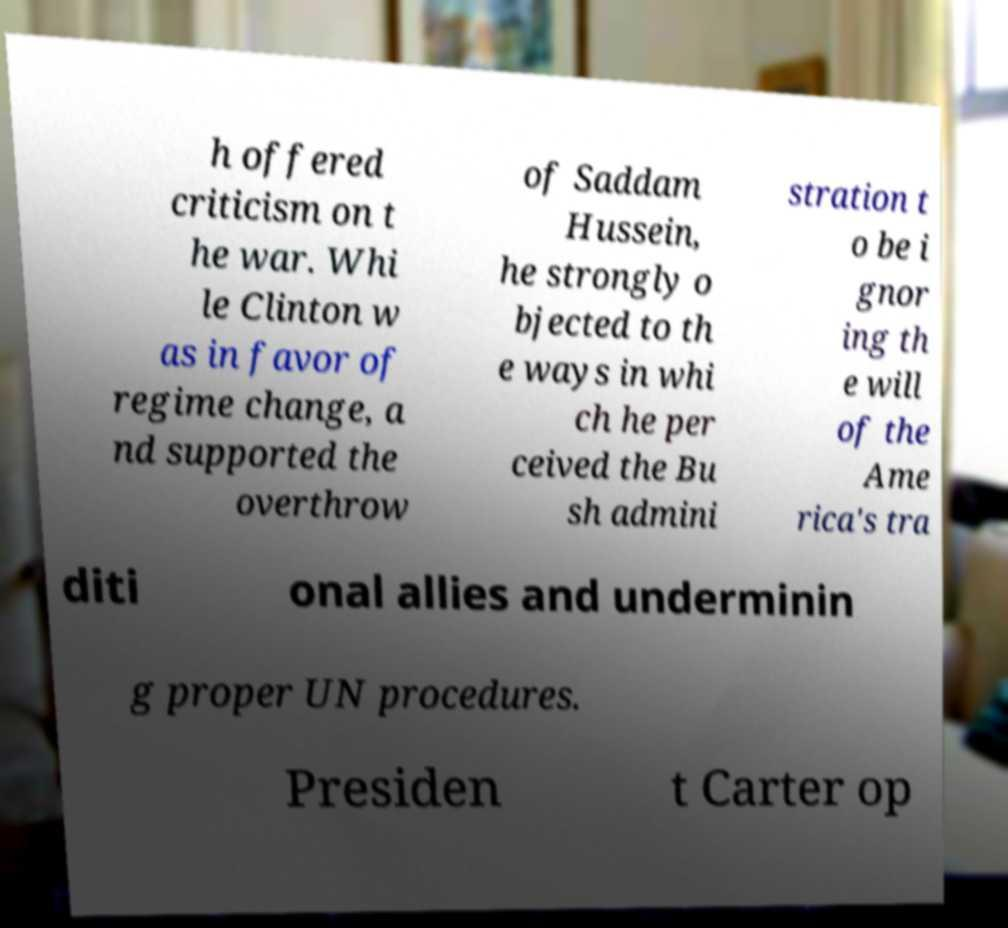For documentation purposes, I need the text within this image transcribed. Could you provide that? h offered criticism on t he war. Whi le Clinton w as in favor of regime change, a nd supported the overthrow of Saddam Hussein, he strongly o bjected to th e ways in whi ch he per ceived the Bu sh admini stration t o be i gnor ing th e will of the Ame rica's tra diti onal allies and underminin g proper UN procedures. Presiden t Carter op 